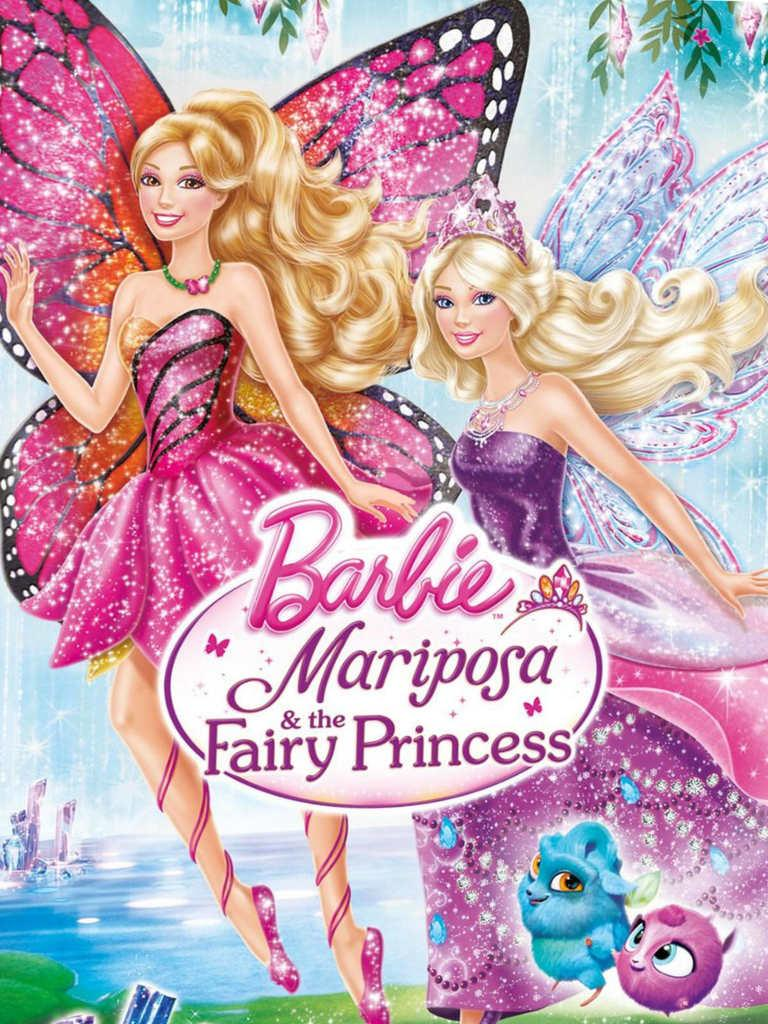What characters are featured on the poster? The poster contains two anime girls. What are the girls wearing? The girls are wearing pink dresses. Do the girls have any special features? Yes, the girls have wings. What can be seen in the background of the poster? There is a water body and two birds in the background of the poster. What degree of difficulty is required to open the door in the image? There is no door present in the image, so the question cannot be answered. 